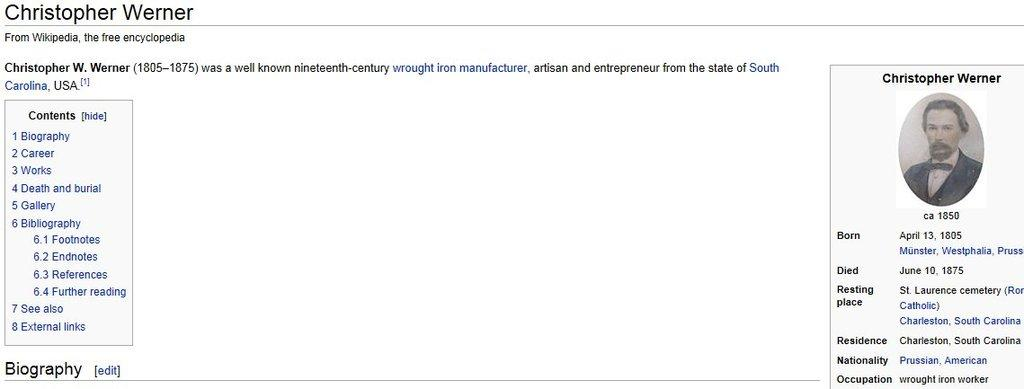What is the main subject of the image? There is an image of a person in the image. What additional information is provided about the person? The person's biography is included. What else can be seen in the image besides the person and their biography? There is some text present. What type of roof is visible in the image? There is no roof present in the image; it features an image of a person and their biography. Can you describe the veins in the person's hand in the image? There is no visible hand or veins in the image; it only shows the person's face and biography. 